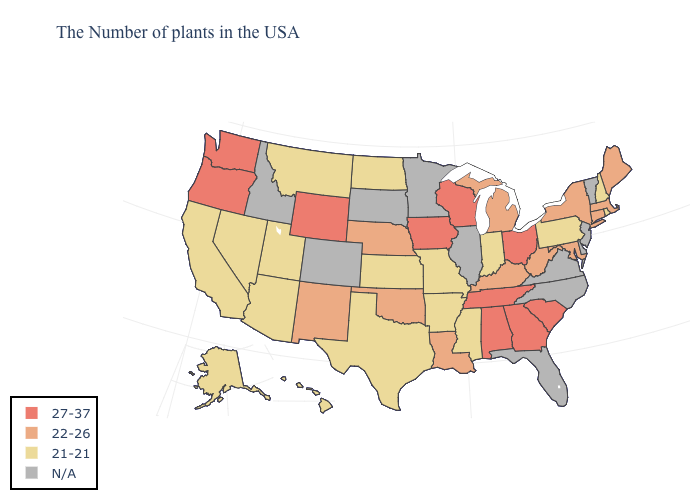What is the value of Maryland?
Concise answer only. 22-26. Name the states that have a value in the range 27-37?
Short answer required. South Carolina, Ohio, Georgia, Alabama, Tennessee, Wisconsin, Iowa, Wyoming, Washington, Oregon. Name the states that have a value in the range 21-21?
Quick response, please. Rhode Island, New Hampshire, Pennsylvania, Indiana, Mississippi, Missouri, Arkansas, Kansas, Texas, North Dakota, Utah, Montana, Arizona, Nevada, California, Alaska, Hawaii. Name the states that have a value in the range 27-37?
Be succinct. South Carolina, Ohio, Georgia, Alabama, Tennessee, Wisconsin, Iowa, Wyoming, Washington, Oregon. Among the states that border Virginia , which have the lowest value?
Write a very short answer. Maryland, West Virginia, Kentucky. Name the states that have a value in the range 21-21?
Short answer required. Rhode Island, New Hampshire, Pennsylvania, Indiana, Mississippi, Missouri, Arkansas, Kansas, Texas, North Dakota, Utah, Montana, Arizona, Nevada, California, Alaska, Hawaii. Does the map have missing data?
Keep it brief. Yes. What is the value of Arizona?
Quick response, please. 21-21. What is the value of South Carolina?
Give a very brief answer. 27-37. Is the legend a continuous bar?
Answer briefly. No. What is the value of Mississippi?
Short answer required. 21-21. Among the states that border Mississippi , which have the highest value?
Write a very short answer. Alabama, Tennessee. Name the states that have a value in the range N/A?
Answer briefly. Vermont, New Jersey, Delaware, Virginia, North Carolina, Florida, Illinois, Minnesota, South Dakota, Colorado, Idaho. Name the states that have a value in the range 22-26?
Concise answer only. Maine, Massachusetts, Connecticut, New York, Maryland, West Virginia, Michigan, Kentucky, Louisiana, Nebraska, Oklahoma, New Mexico. 